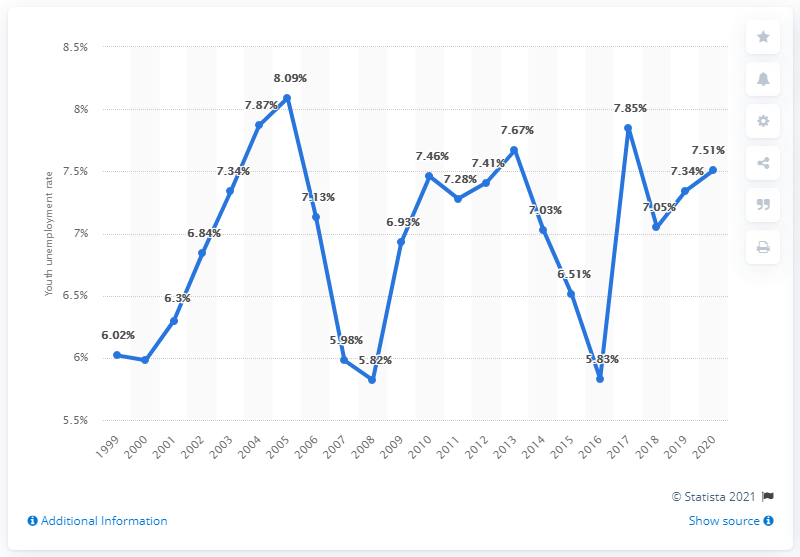Draw attention to some important aspects in this diagram. The youth unemployment rate in the United Arab Emirates in 2020 was 7.51%. 